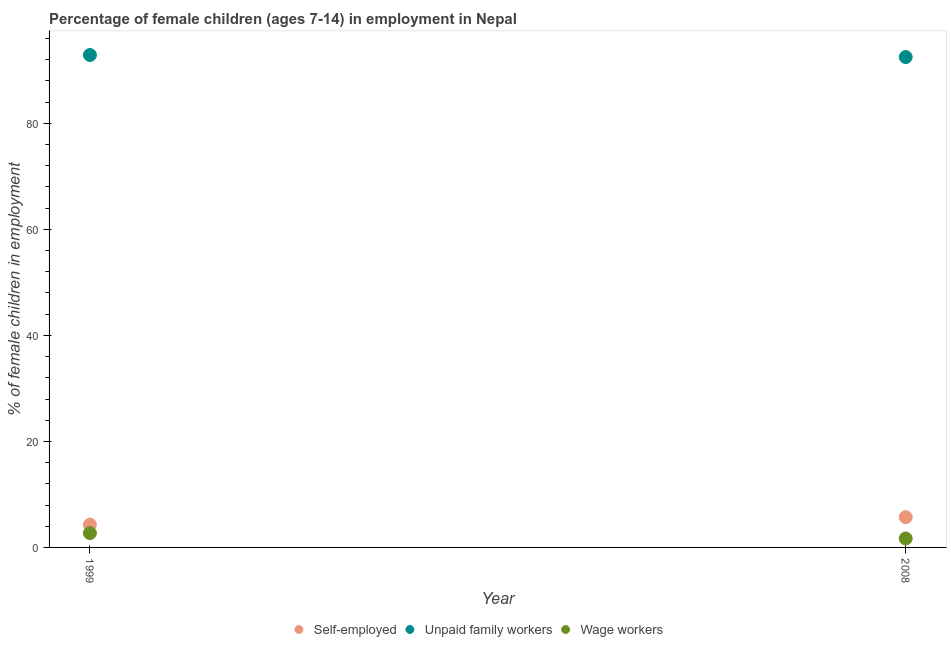How many different coloured dotlines are there?
Your answer should be very brief. 3. Is the number of dotlines equal to the number of legend labels?
Provide a short and direct response. Yes. What is the percentage of children employed as unpaid family workers in 1999?
Your answer should be very brief. 92.9. Across all years, what is the maximum percentage of children employed as unpaid family workers?
Keep it short and to the point. 92.9. Across all years, what is the minimum percentage of children employed as wage workers?
Give a very brief answer. 1.69. In which year was the percentage of children employed as unpaid family workers maximum?
Ensure brevity in your answer.  1999. What is the total percentage of children employed as unpaid family workers in the graph?
Offer a very short reply. 185.41. What is the difference between the percentage of self employed children in 1999 and that in 2008?
Offer a terse response. -1.41. What is the difference between the percentage of children employed as unpaid family workers in 1999 and the percentage of self employed children in 2008?
Offer a terse response. 87.19. What is the average percentage of children employed as wage workers per year?
Provide a short and direct response. 2.2. In the year 2008, what is the difference between the percentage of self employed children and percentage of children employed as unpaid family workers?
Provide a succinct answer. -86.8. What is the ratio of the percentage of self employed children in 1999 to that in 2008?
Make the answer very short. 0.75. Does the percentage of children employed as unpaid family workers monotonically increase over the years?
Provide a succinct answer. No. Is the percentage of children employed as unpaid family workers strictly less than the percentage of children employed as wage workers over the years?
Provide a short and direct response. No. How many dotlines are there?
Offer a terse response. 3. Does the graph contain grids?
Your answer should be compact. No. What is the title of the graph?
Keep it short and to the point. Percentage of female children (ages 7-14) in employment in Nepal. Does "Transport equipments" appear as one of the legend labels in the graph?
Ensure brevity in your answer.  No. What is the label or title of the X-axis?
Give a very brief answer. Year. What is the label or title of the Y-axis?
Offer a very short reply. % of female children in employment. What is the % of female children in employment in Self-employed in 1999?
Ensure brevity in your answer.  4.3. What is the % of female children in employment of Unpaid family workers in 1999?
Ensure brevity in your answer.  92.9. What is the % of female children in employment in Self-employed in 2008?
Provide a succinct answer. 5.71. What is the % of female children in employment in Unpaid family workers in 2008?
Offer a very short reply. 92.51. What is the % of female children in employment of Wage workers in 2008?
Offer a terse response. 1.69. Across all years, what is the maximum % of female children in employment in Self-employed?
Make the answer very short. 5.71. Across all years, what is the maximum % of female children in employment in Unpaid family workers?
Offer a very short reply. 92.9. Across all years, what is the minimum % of female children in employment in Unpaid family workers?
Make the answer very short. 92.51. Across all years, what is the minimum % of female children in employment of Wage workers?
Make the answer very short. 1.69. What is the total % of female children in employment in Self-employed in the graph?
Keep it short and to the point. 10.01. What is the total % of female children in employment in Unpaid family workers in the graph?
Offer a terse response. 185.41. What is the total % of female children in employment of Wage workers in the graph?
Offer a terse response. 4.39. What is the difference between the % of female children in employment in Self-employed in 1999 and that in 2008?
Provide a succinct answer. -1.41. What is the difference between the % of female children in employment in Unpaid family workers in 1999 and that in 2008?
Your answer should be compact. 0.39. What is the difference between the % of female children in employment of Self-employed in 1999 and the % of female children in employment of Unpaid family workers in 2008?
Make the answer very short. -88.21. What is the difference between the % of female children in employment of Self-employed in 1999 and the % of female children in employment of Wage workers in 2008?
Your answer should be very brief. 2.61. What is the difference between the % of female children in employment in Unpaid family workers in 1999 and the % of female children in employment in Wage workers in 2008?
Offer a very short reply. 91.21. What is the average % of female children in employment of Self-employed per year?
Give a very brief answer. 5. What is the average % of female children in employment in Unpaid family workers per year?
Offer a very short reply. 92.7. What is the average % of female children in employment of Wage workers per year?
Offer a very short reply. 2.19. In the year 1999, what is the difference between the % of female children in employment in Self-employed and % of female children in employment in Unpaid family workers?
Provide a short and direct response. -88.6. In the year 1999, what is the difference between the % of female children in employment in Self-employed and % of female children in employment in Wage workers?
Keep it short and to the point. 1.6. In the year 1999, what is the difference between the % of female children in employment in Unpaid family workers and % of female children in employment in Wage workers?
Ensure brevity in your answer.  90.2. In the year 2008, what is the difference between the % of female children in employment in Self-employed and % of female children in employment in Unpaid family workers?
Your response must be concise. -86.8. In the year 2008, what is the difference between the % of female children in employment of Self-employed and % of female children in employment of Wage workers?
Offer a very short reply. 4.02. In the year 2008, what is the difference between the % of female children in employment of Unpaid family workers and % of female children in employment of Wage workers?
Keep it short and to the point. 90.82. What is the ratio of the % of female children in employment of Self-employed in 1999 to that in 2008?
Your answer should be very brief. 0.75. What is the ratio of the % of female children in employment of Wage workers in 1999 to that in 2008?
Keep it short and to the point. 1.6. What is the difference between the highest and the second highest % of female children in employment in Self-employed?
Offer a very short reply. 1.41. What is the difference between the highest and the second highest % of female children in employment of Unpaid family workers?
Provide a short and direct response. 0.39. What is the difference between the highest and the lowest % of female children in employment in Self-employed?
Provide a succinct answer. 1.41. What is the difference between the highest and the lowest % of female children in employment of Unpaid family workers?
Give a very brief answer. 0.39. What is the difference between the highest and the lowest % of female children in employment of Wage workers?
Your response must be concise. 1.01. 